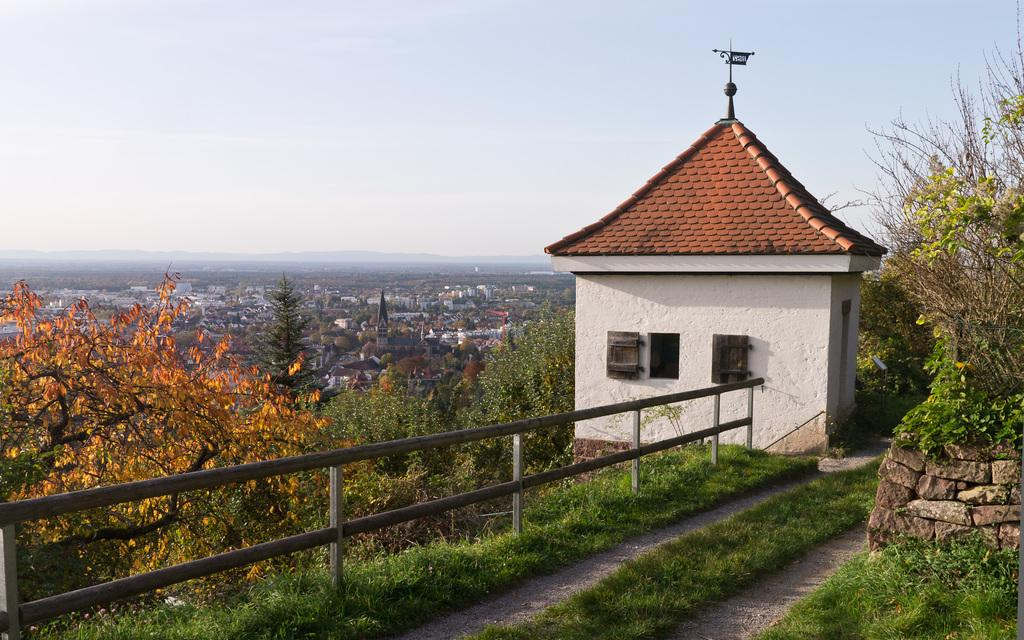What type of structure is present in the image? There is a shed in the image. What architectural feature can be seen in the image? There is railing in the image. What type of ground surface is visible in the image? There are stones in the image. What type of vegetation is present in the image? There is grass, plants, and trees in the image. What type of man-made structures are present in the image? There are buildings in the image. What part of the natural environment is visible in the image? The sky is visible in the image. Can you see any fangs in the image? There are no fangs present in the image. What type of shock can be seen in the image? There is no shock present in the image. Is there any quicksand visible in the image? There is no quicksand present in the image. 